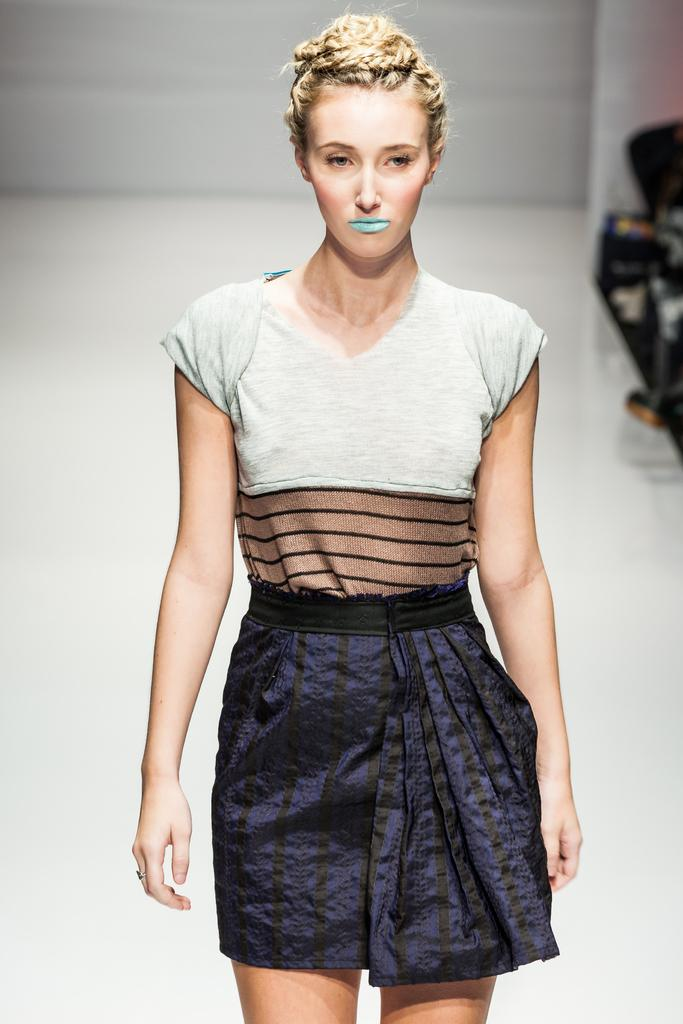Who is present in the image? There is a woman in the image. What is the woman wearing? The woman is wearing a dress with white, black, brown, and purple colors. What can be seen in the background of the image? There is a white-colored floor and a wall in the background of the image. What type of reward is the woman receiving in the image? There is no indication in the image that the woman is receiving any reward, so it cannot be determined from the picture. 